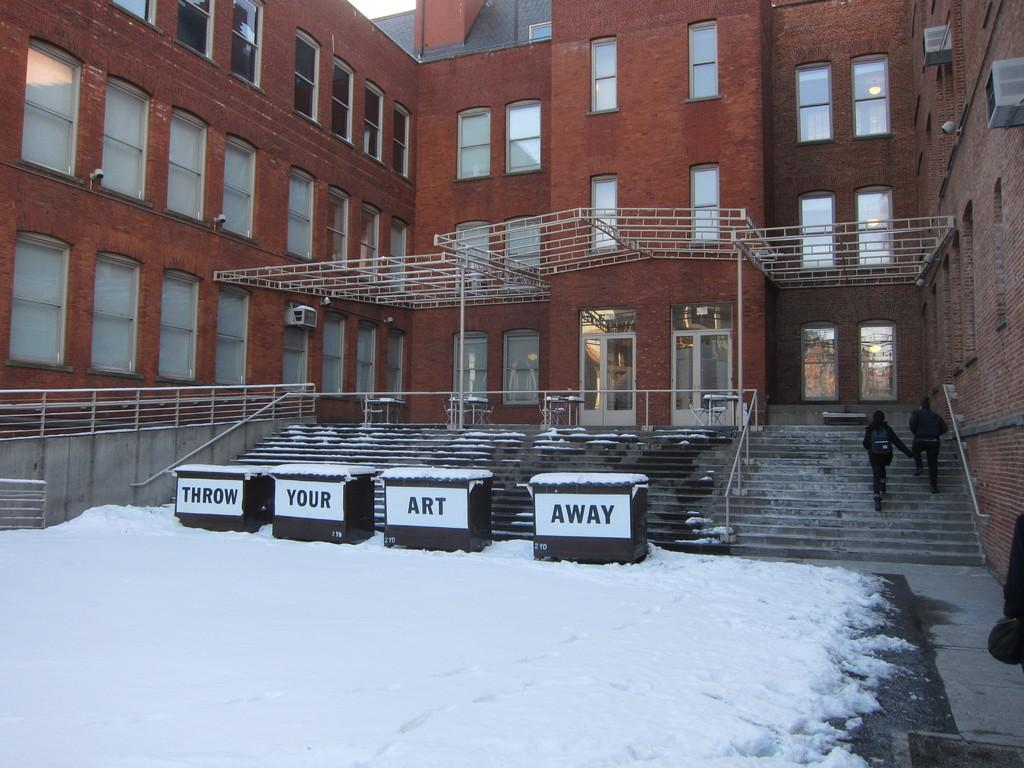What is the main subject of the image? The main subject of the image is boxes on snow. What can be seen on the boxes? The boxes have text on them. What are the two people in the image doing? The two people are walking on steps in the image. What feature is present to provide support or safety while walking? Railings are visible in the image. What type of structure is visible in the image? There is a building with windows in the image. Are there any other objects present in the image besides the boxes, people, and building? Yes, there are other objects present in the image. What type of arch can be seen in the image? There is no arch present in the image. Can you hear the bell ringing in the image? There is no bell present in the image, so it cannot be heard. 